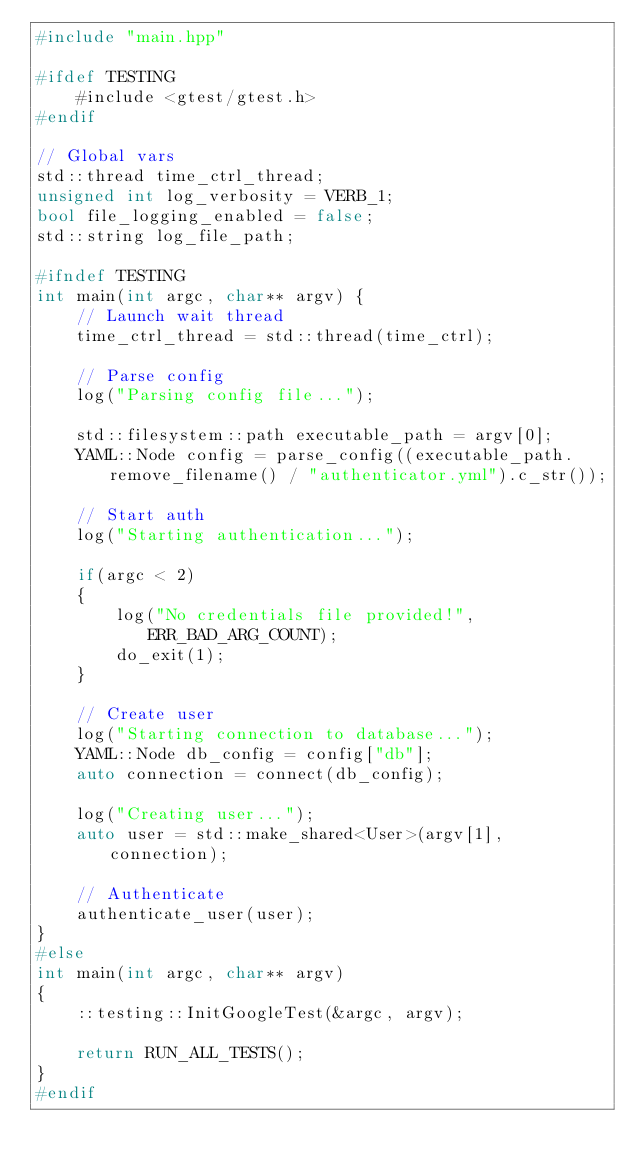Convert code to text. <code><loc_0><loc_0><loc_500><loc_500><_C++_>#include "main.hpp"

#ifdef TESTING
    #include <gtest/gtest.h>
#endif

// Global vars
std::thread time_ctrl_thread;
unsigned int log_verbosity = VERB_1;
bool file_logging_enabled = false;
std::string log_file_path;

#ifndef TESTING
int main(int argc, char** argv) {
    // Launch wait thread
    time_ctrl_thread = std::thread(time_ctrl);

    // Parse config
    log("Parsing config file...");

    std::filesystem::path executable_path = argv[0];
    YAML::Node config = parse_config((executable_path.remove_filename() / "authenticator.yml").c_str());

    // Start auth
    log("Starting authentication...");

    if(argc < 2)
    {
        log("No credentials file provided!", ERR_BAD_ARG_COUNT);
        do_exit(1);
    }

    // Create user
    log("Starting connection to database...");
    YAML::Node db_config = config["db"];
    auto connection = connect(db_config);

    log("Creating user...");
    auto user = std::make_shared<User>(argv[1], connection);

    // Authenticate
    authenticate_user(user);
}
#else
int main(int argc, char** argv)
{
    ::testing::InitGoogleTest(&argc, argv);

    return RUN_ALL_TESTS();
}
#endif</code> 